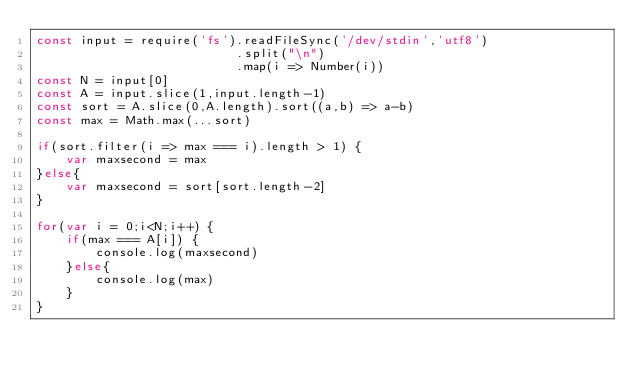<code> <loc_0><loc_0><loc_500><loc_500><_JavaScript_>const input = require('fs').readFileSync('/dev/stdin','utf8')
                           .split("\n")
                           .map(i => Number(i))
const N = input[0]
const A = input.slice(1,input.length-1)
const sort = A.slice(0,A.length).sort((a,b) => a-b)
const max = Math.max(...sort)

if(sort.filter(i => max === i).length > 1) {
    var maxsecond = max
}else{
    var maxsecond = sort[sort.length-2]
}

for(var i = 0;i<N;i++) {
    if(max === A[i]) {
        console.log(maxsecond)
    }else{
        console.log(max)
    }
}</code> 